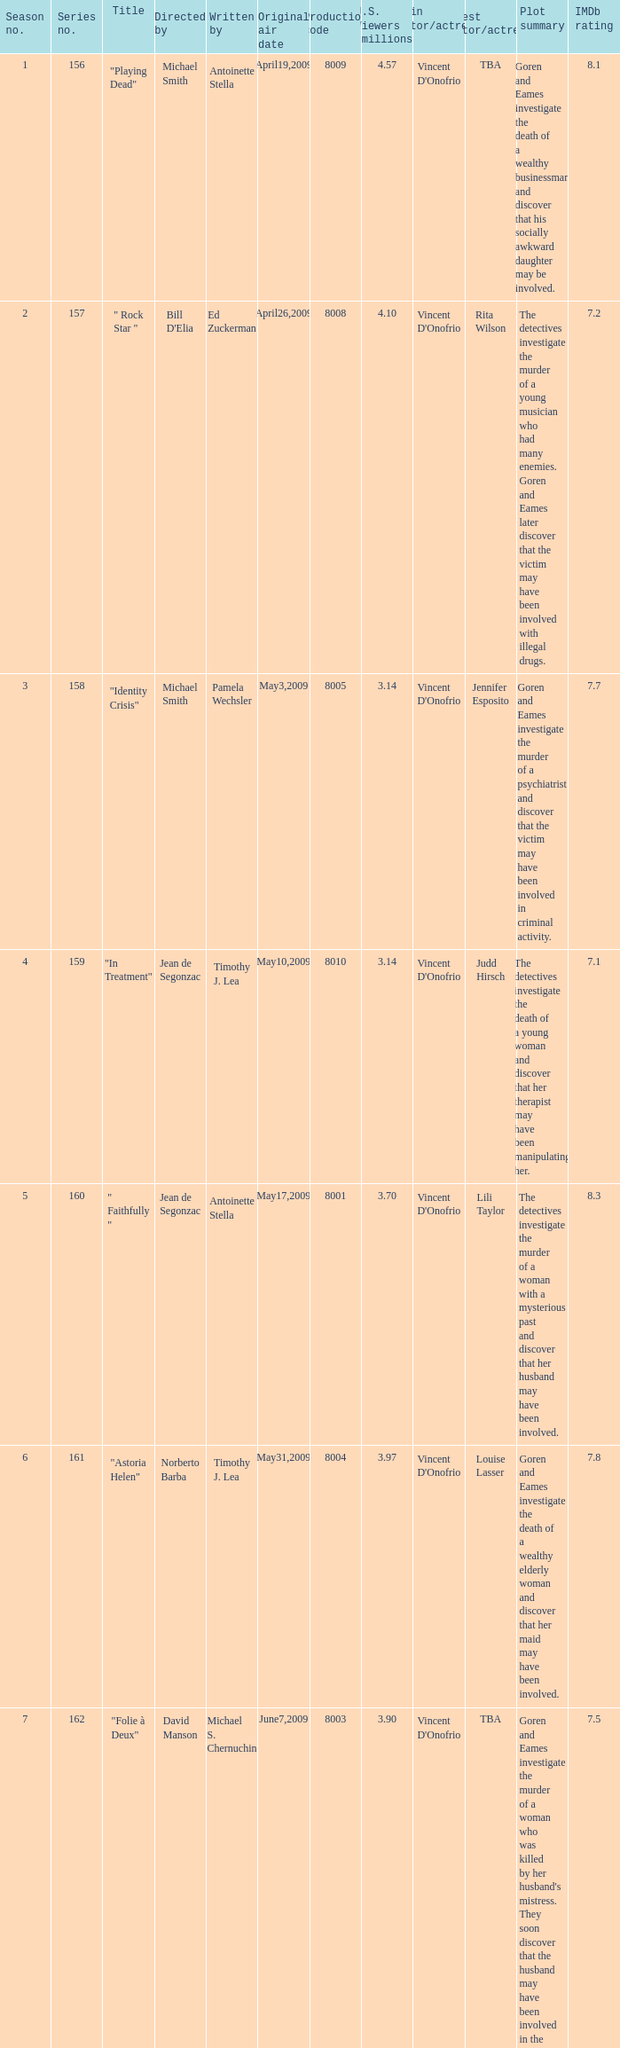Which is the  maximun serie episode number when the millions of north american spectators is 3.14? 159.0. Can you give me this table as a dict? {'header': ['Season no.', 'Series no.', 'Title', 'Directed by', 'Written by', 'Original air date', 'Production code', 'U.S. Viewers (millions)', 'Main actor/actress', 'Guest actor/actress', 'Plot summary', 'IMDb rating'], 'rows': [['1', '156', '"Playing Dead"', 'Michael Smith', 'Antoinette Stella', 'April19,2009', '8009', '4.57', "Vincent D'Onofrio", 'TBA', 'Goren and Eames investigate the death of a wealthy businessman and discover that his socially awkward daughter may be involved.', '8.1'], ['2', '157', '" Rock Star "', "Bill D'Elia", 'Ed Zuckerman', 'April26,2009', '8008', '4.10', "Vincent D'Onofrio", 'Rita Wilson', 'The detectives investigate the murder of a young musician who had many enemies. Goren and Eames later discover that the victim may have been involved with illegal drugs.', '7.2'], ['3', '158', '"Identity Crisis"', 'Michael Smith', 'Pamela Wechsler', 'May3,2009', '8005', '3.14', "Vincent D'Onofrio", 'Jennifer Esposito', 'Goren and Eames investigate the murder of a psychiatrist and discover that the victim may have been involved in criminal activity.', '7.7'], ['4', '159', '"In Treatment"', 'Jean de Segonzac', 'Timothy J. Lea', 'May10,2009', '8010', '3.14', "Vincent D'Onofrio", 'Judd Hirsch', 'The detectives investigate the death of a young woman and discover that her therapist may have been manipulating her.', '7.1'], ['5', '160', '" Faithfully "', 'Jean de Segonzac', 'Antoinette Stella', 'May17,2009', '8001', '3.70', "Vincent D'Onofrio", 'Lili Taylor', 'The detectives investigate the murder of a woman with a mysterious past and discover that her husband may have been involved.', '8.3'], ['6', '161', '"Astoria Helen"', 'Norberto Barba', 'Timothy J. Lea', 'May31,2009', '8004', '3.97', "Vincent D'Onofrio", 'Louise Lasser', 'Goren and Eames investigate the death of a wealthy elderly woman and discover that her maid may have been involved.', '7.8'], ['7', '162', '"Folie à Deux"', 'David Manson', 'Michael S. Chernuchin', 'June7,2009', '8003', '3.90', "Vincent D'Onofrio", 'TBA', "Goren and Eames investigate the murder of a woman who was killed by her husband's mistress. They soon discover that the husband may have been involved in the crime as well.", '7.5'], ['8', '163', '" The Glory That Was... "', 'Norberto Barba', 'Robert Nathan', 'June14,2009', '8002', '4.14', "Vincent D'Onofrio", 'Alicia Coppola', 'The detectives investigate the murder of a museum curator and discover that the victim may have been involved in the illegal trade of antiquities.', '7.6'], ['10', '165', '"Salome in Manhattan" "Salome"', 'Steve Shill', 'Andrew Lipsitz', 'June28,2009', '8006', 'N/A', 'Jeff Goldblum', 'Mary Elizabeth Mastrantonio', 'Goren and Eames investigate the death of a Broadway dancer and discover that her rivalry with another performer may have played a role in her murder.', '7.0'], ['11', '166', '"Lady\'s Man"', 'Ken Girotti', 'Michael S. Chernuchin', 'June28,2009', '8011', 'N/A', 'Jeff Goldblum', 'TBA', 'The detectives investigate the murder of a woman who had affairs with multiple men. They soon discover that the victim may have been involved in illegal activity.', '7.4'], ['12', '167', '"Passion"', 'Jonathan Herron', 'Michael S. Chernuchin', 'July12,2009', '8012', '3.47', 'Jeff Goldblum', 'TBA', 'Goren and Eames investigate the murder of a young woman and discover that the victim was involved in a dangerous love triangle.', '7.9'], ['14', '169', '" Major Case "', 'Chris Zalla', 'Andrew Lipsitz', 'July26,2009', '8014', '4.63', 'Jeff Goldblum', 'TBA', 'The detectives investigate the murder of a veteran who may have been involved in illegal activity. Goren and Eames later discover that the victim may have been a valuable witness in a major case.', '7.2'], ['15', '170', '"Alpha Dog"', 'Norberto Barba', 'Walon Green', 'August2,2009', '8007', '4.23', 'Jeff Goldblum', 'TBA', 'Goren and Eames investigate the murder of a dog breeder and discover that the victim may have been involved in illegal dog fighting.', '7.7']]} 